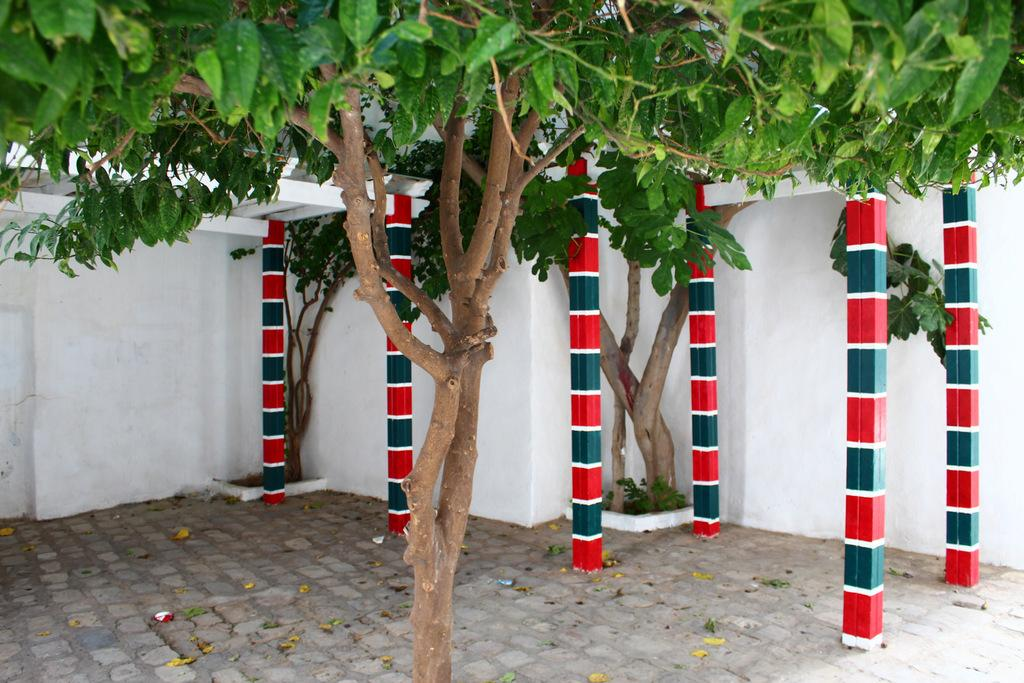Where was the picture taken? The picture was clicked outside. What can be seen in the foreground of the image? There is a tree in the foreground of the image. What is located in the center of the image? There is a wall, pillars, trees, plants, and other items in the center of the image. Can you see a giraffe in the image? No, there is no giraffe present in the image. What type of power source is visible in the image? There is no power source visible in the image. 